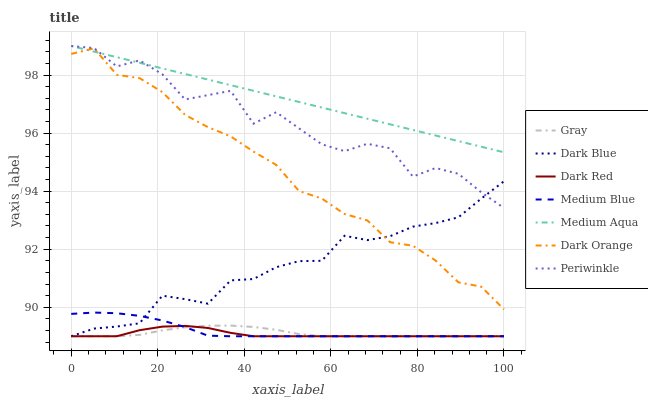Does Dark Red have the minimum area under the curve?
Answer yes or no. Yes. Does Medium Aqua have the maximum area under the curve?
Answer yes or no. Yes. Does Dark Orange have the minimum area under the curve?
Answer yes or no. No. Does Dark Orange have the maximum area under the curve?
Answer yes or no. No. Is Medium Aqua the smoothest?
Answer yes or no. Yes. Is Periwinkle the roughest?
Answer yes or no. Yes. Is Dark Orange the smoothest?
Answer yes or no. No. Is Dark Orange the roughest?
Answer yes or no. No. Does Gray have the lowest value?
Answer yes or no. Yes. Does Dark Orange have the lowest value?
Answer yes or no. No. Does Periwinkle have the highest value?
Answer yes or no. Yes. Does Dark Orange have the highest value?
Answer yes or no. No. Is Gray less than Dark Orange?
Answer yes or no. Yes. Is Medium Aqua greater than Gray?
Answer yes or no. Yes. Does Dark Blue intersect Dark Orange?
Answer yes or no. Yes. Is Dark Blue less than Dark Orange?
Answer yes or no. No. Is Dark Blue greater than Dark Orange?
Answer yes or no. No. Does Gray intersect Dark Orange?
Answer yes or no. No. 